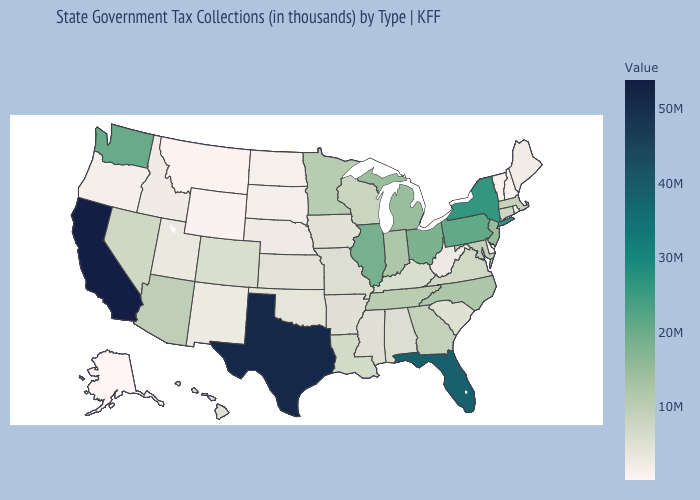Does Washington have a lower value than Florida?
Concise answer only. Yes. Does the map have missing data?
Concise answer only. No. Which states have the lowest value in the USA?
Give a very brief answer. Alaska. Which states have the lowest value in the South?
Write a very short answer. Delaware. Which states hav the highest value in the Northeast?
Answer briefly. New York. 